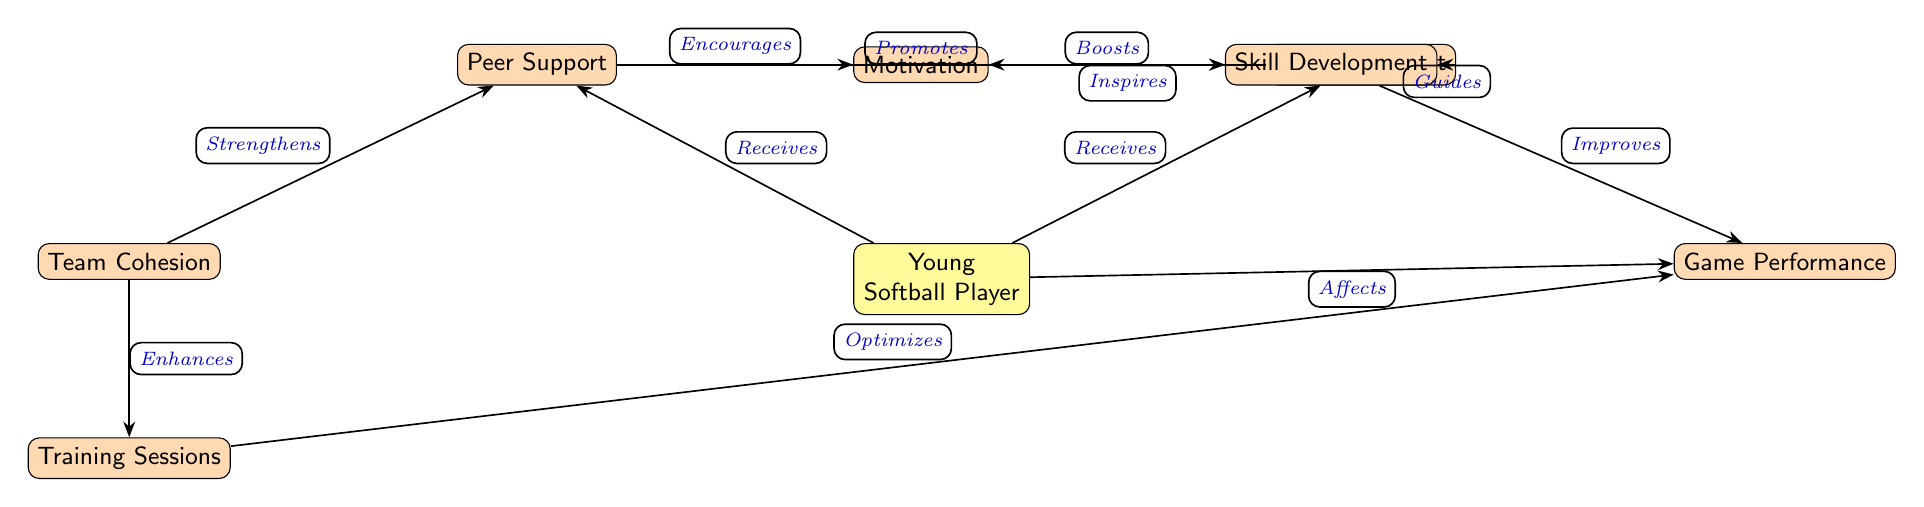What is the main node at the center of the diagram? The center node is labeled "Young Softball Player," which indicates that it is the primary subject of the relationships and influences represented in the diagram.
Answer: Young Softball Player How many nodes are in the diagram? To find the number of nodes, count each independent entity in the diagram. There are 7 nodes total: Young Softball Player, Peer Support, Mentor Support, Motivation, Skill Development, Team Cohesion, Training Sessions, Game Performance.
Answer: 7 What does "Peer Support" encourage? The edge labeled "Encourages" connects "Peer Support" to "Motivation," indicating that the influence of peer support is directed towards enhancing the motivation of the young athlete.
Answer: Motivation Which node receives support from "Mentor Support"? The edge from "Mentor Support" points towards "Young Softball Player" indicating that the player receives guidance and influence from mentors.
Answer: Young Softball Player What effect does "Motivation" have on "Skill Development"? The relationship specified by the edge "Boosts" indicates that there is a direct positive impact of "Motivation" on "Skill Development," suggesting that increased motivation leads to improved skills.
Answer: Boosts How does "Team Cohesion" affect "Peer Support"? The diagram shows an edge that indicates "Team Cohesion" "Strengthens" "Peer Support," highlighting the role of team dynamics in enhancing the support young athletes receive from their peers.
Answer: Strengthens What node does "Skill Development" improve? The edge labeled "Improves" connects "Skill Development" to "Game Performance," suggesting that as skills develop, the performance in games will also get better.
Answer: Game Performance What is directed from "Training Sessions" to "Game Performance"? The relationship is represented by the edge labeled "Optimizes," indicating that effective training sessions directly contribute to enhancing the performance in games.
Answer: Optimizes What is the relationship type between "Mentor Support" and "Skill Development"? The edge from "Mentor Support" to "Skill Development" is labeled "Guides," indicating that the support from a mentor helps in facilitating and guiding the skill development process.
Answer: Guides 